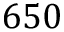Convert formula to latex. <formula><loc_0><loc_0><loc_500><loc_500>6 5 0</formula> 